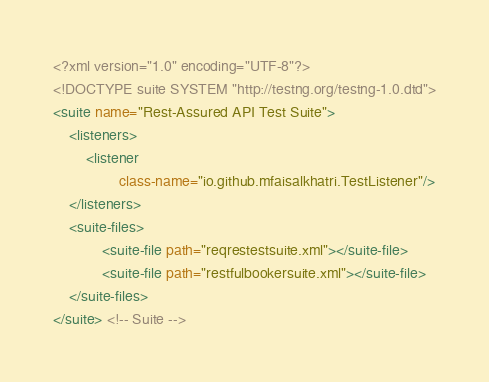Convert code to text. <code><loc_0><loc_0><loc_500><loc_500><_XML_><?xml version="1.0" encoding="UTF-8"?>
<!DOCTYPE suite SYSTEM "http://testng.org/testng-1.0.dtd">
<suite name="Rest-Assured API Test Suite">
    <listeners>
        <listener
                class-name="io.github.mfaisalkhatri.TestListener"/>
    </listeners>
    <suite-files>
            <suite-file path="reqrestestsuite.xml"></suite-file>
            <suite-file path="restfulbookersuite.xml"></suite-file>
    </suite-files>
</suite> <!-- Suite --></code> 